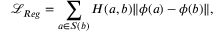Convert formula to latex. <formula><loc_0><loc_0><loc_500><loc_500>\mathcal { L } _ { R e g } = \sum _ { a \in S ( b ) } H ( a , b ) \| \phi ( a ) - \phi ( b ) \| ,</formula> 